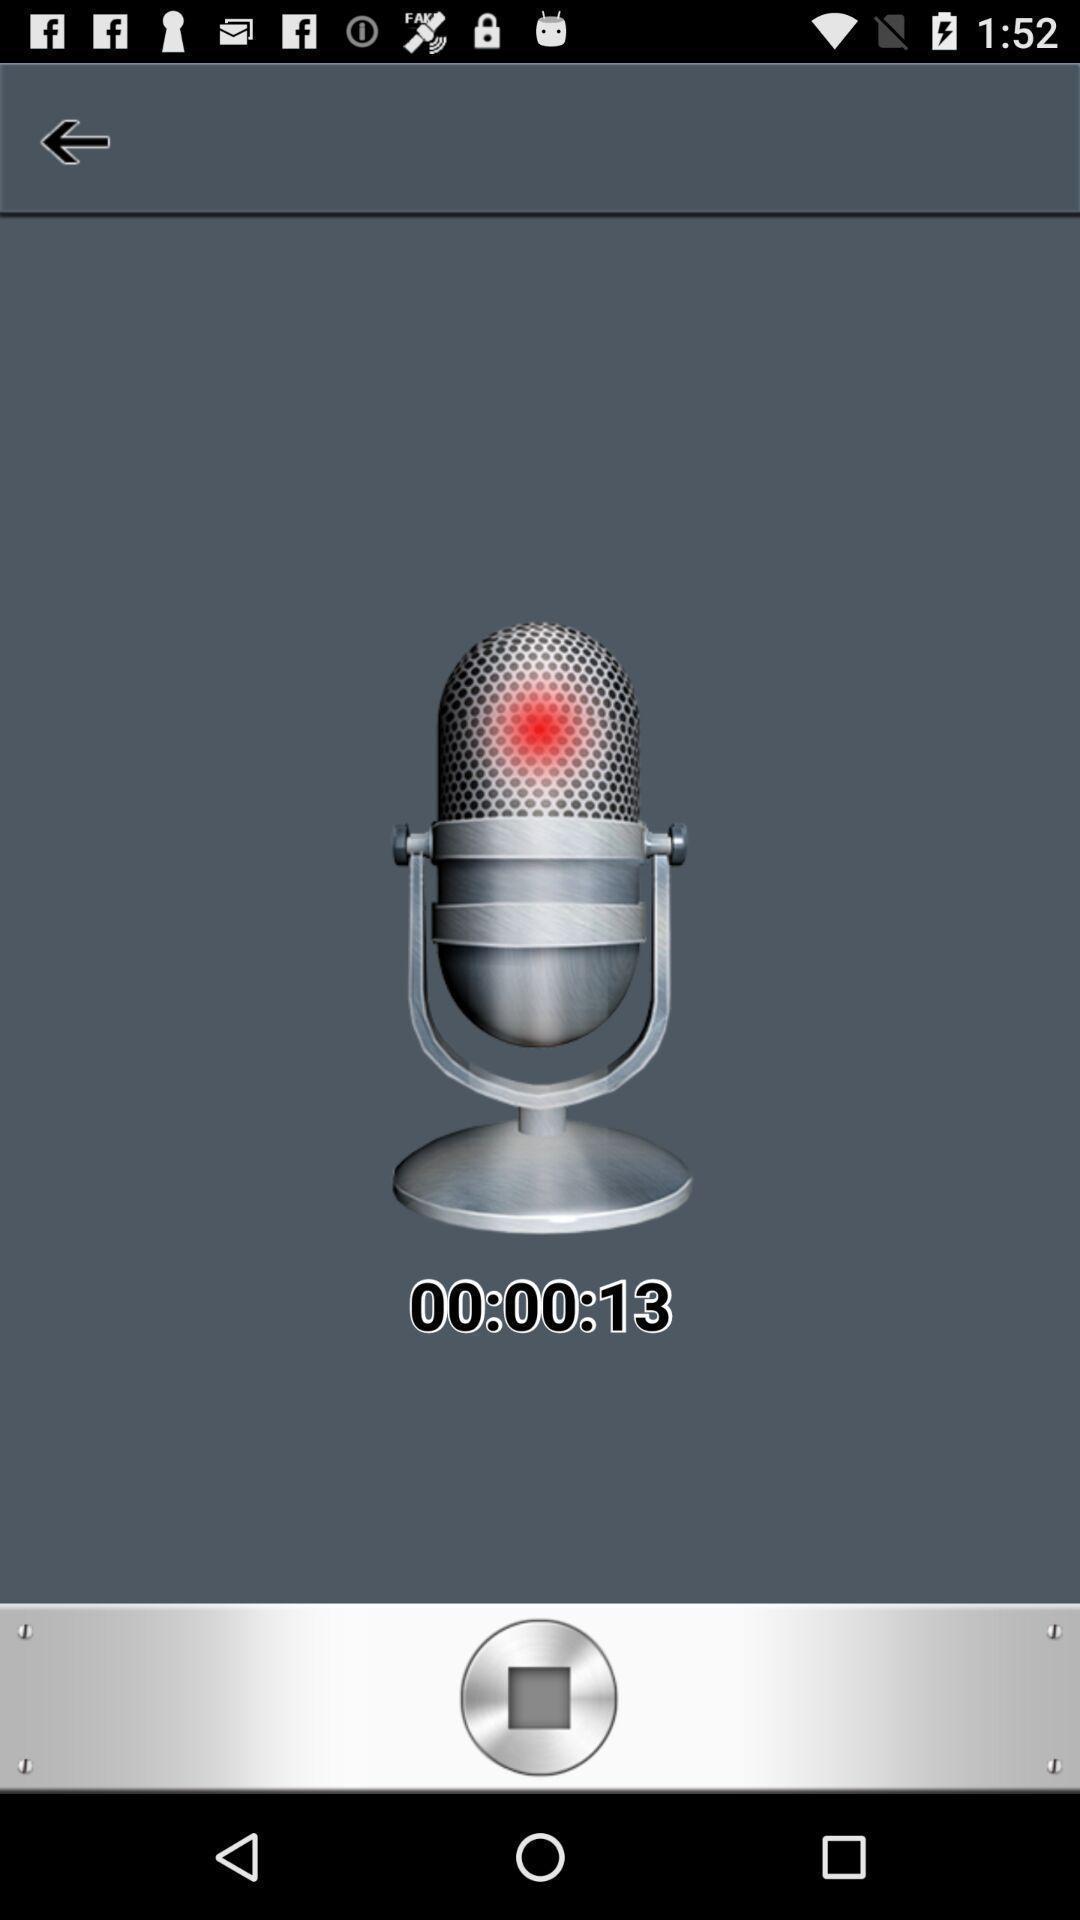What details can you identify in this image? Screen shows a microphone. 